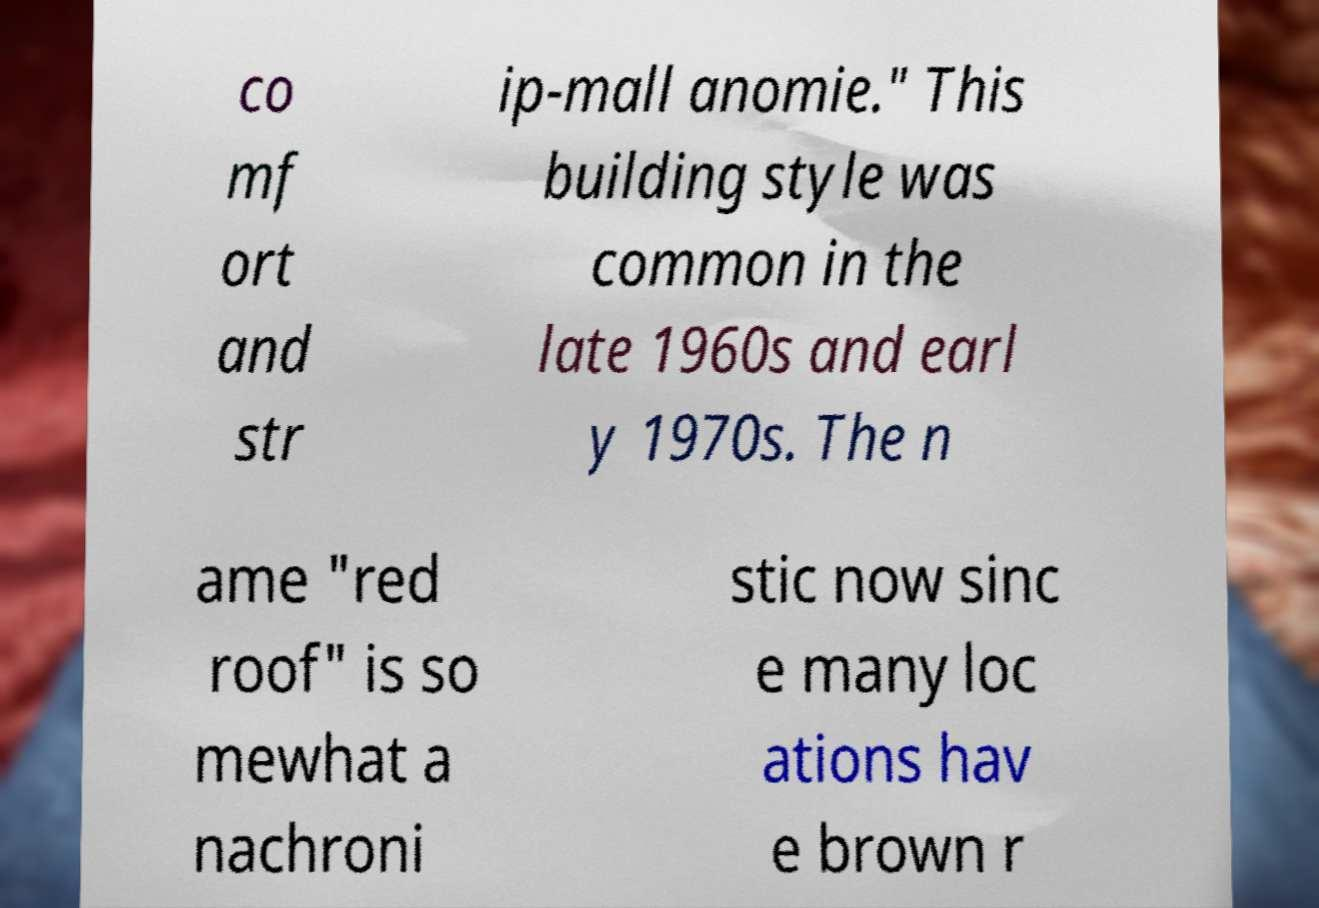Can you accurately transcribe the text from the provided image for me? co mf ort and str ip-mall anomie." This building style was common in the late 1960s and earl y 1970s. The n ame "red roof" is so mewhat a nachroni stic now sinc e many loc ations hav e brown r 